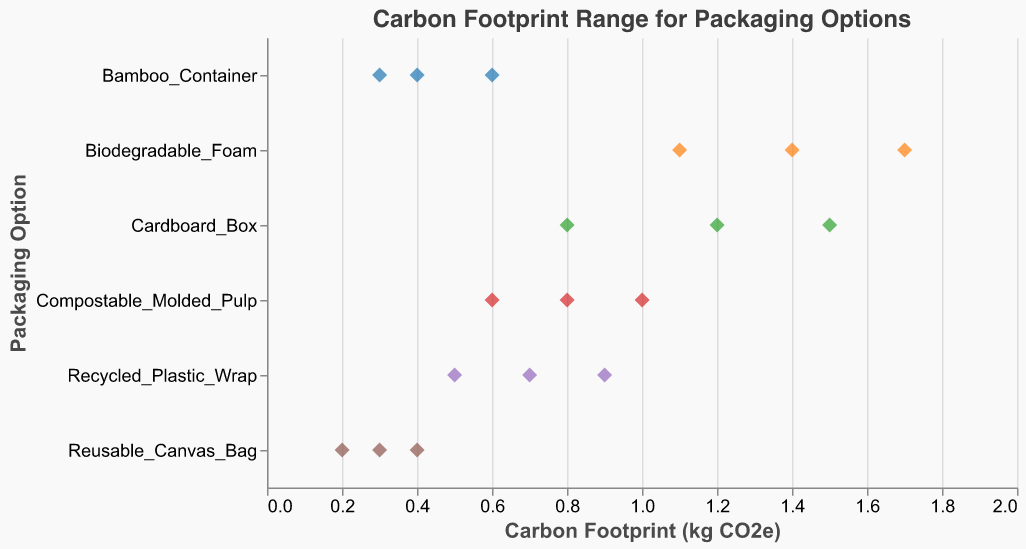What is the title of the figure? The title is typically located at the top center of the chart.
Answer: Carbon Footprint Range for Packaging Options What is the range of carbon footprint values for the Cardboard_Box packaging option? The Carbon Footprint values for Cardboard_Box can be found by identifying the points on the x-axis corresponding to this option on the y-axis. The values are 0.8, 1.2, and 1.5 kg CO2e.
Answer: 0.8 to 1.5 kg CO2e Which packaging option has the lowest carbon footprint, and what is the value? By evaluating the minimum value on the x-axis for each packaging option, the lowest point is 0.2 kg CO2e, associated with Reusable_Canvas_Bag.
Answer: Reusable_Canvas_Bag, 0.2 kg CO2e How many data points are there for the Biodegradable_Foam packaging option? Counting the number of points along the x-axis for Biodegradable_Foam on the y-axis, we find 3 data points.
Answer: 3 What is the average carbon footprint of Recycled_Plastic_Wrap? Adding the values (0.5, 0.7, 0.9) and then dividing by the number of points (3) gives (0.5 + 0.7 + 0.9) / 3 = 2.1 / 3 = 0.7 kg CO2e.
Answer: 0.7 kg CO2e Which packaging option has the highest maximum carbon footprint, and what is the value? By examining the maximum values on the x-axis for each packaging option, the highest point is 1.7 kg CO2e for Biodegradable_Foam.
Answer: Biodegradable_Foam, 1.7 kg CO2e What is the median value of the Compostable_Molded_Pulp packaging option? The median is the middle value of the sorted data points (0.6, 0.8, 1.0). The middle value is 0.8 kg CO2e.
Answer: 0.8 kg CO2e Which packaging option shows the smallest range in carbon footprint values? By calculating the range for each packaging option, the smallest range is for Reusable_Canvas_Bag (0.4 - 0.2 = 0.2 kg CO2e).
Answer: Reusable_Canvas_Bag How does the range of carbon footprints for Bamboo_Container compare to that of Cardboard_Box? Bamboo_Container has a range of 0.6 - 0.3 = 0.3 kg CO2e, while Cardboard_Box has a range of 1.5 - 0.8 = 0.7 kg CO2e. Bamboo_Container has a smaller range.
Answer: Smaller range for Bamboo_Container What is the total number of data points plotted in the figure? Counting the total data points for each packaging option (3 each for six options), we find 3 * 6 = 18 data points.
Answer: 18 